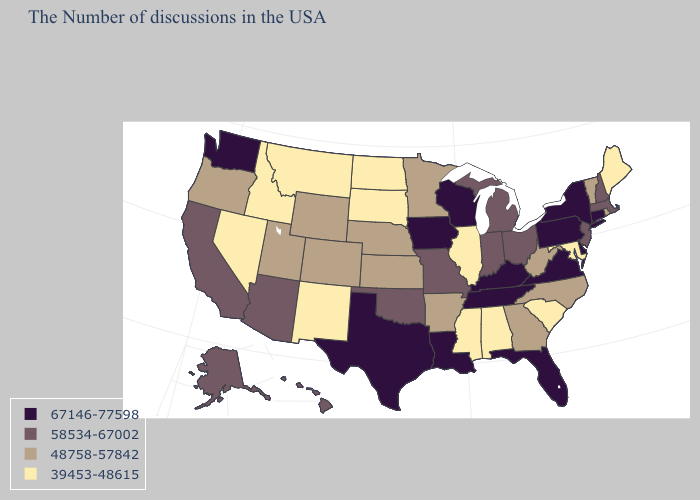Among the states that border Delaware , which have the lowest value?
Quick response, please. Maryland. Does Arizona have the lowest value in the USA?
Give a very brief answer. No. Which states have the lowest value in the USA?
Quick response, please. Maine, Maryland, South Carolina, Alabama, Illinois, Mississippi, South Dakota, North Dakota, New Mexico, Montana, Idaho, Nevada. Which states have the lowest value in the West?
Quick response, please. New Mexico, Montana, Idaho, Nevada. What is the highest value in the USA?
Give a very brief answer. 67146-77598. What is the value of Kentucky?
Give a very brief answer. 67146-77598. What is the lowest value in the West?
Concise answer only. 39453-48615. What is the highest value in the West ?
Be succinct. 67146-77598. Is the legend a continuous bar?
Short answer required. No. Among the states that border Ohio , does Michigan have the highest value?
Be succinct. No. What is the value of Louisiana?
Write a very short answer. 67146-77598. What is the value of Delaware?
Keep it brief. 67146-77598. What is the lowest value in the West?
Concise answer only. 39453-48615. What is the value of Kansas?
Concise answer only. 48758-57842. Name the states that have a value in the range 67146-77598?
Be succinct. Connecticut, New York, Delaware, Pennsylvania, Virginia, Florida, Kentucky, Tennessee, Wisconsin, Louisiana, Iowa, Texas, Washington. 